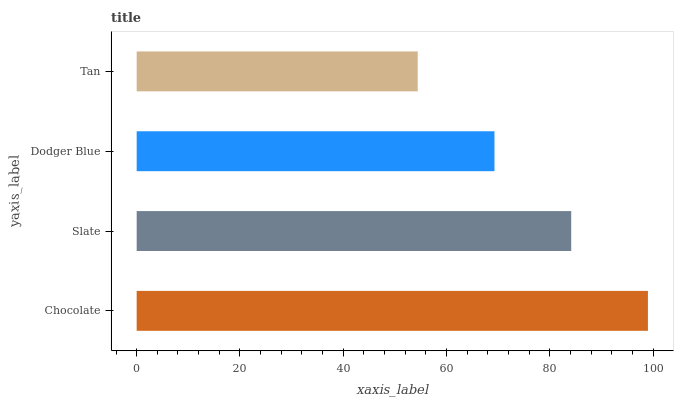Is Tan the minimum?
Answer yes or no. Yes. Is Chocolate the maximum?
Answer yes or no. Yes. Is Slate the minimum?
Answer yes or no. No. Is Slate the maximum?
Answer yes or no. No. Is Chocolate greater than Slate?
Answer yes or no. Yes. Is Slate less than Chocolate?
Answer yes or no. Yes. Is Slate greater than Chocolate?
Answer yes or no. No. Is Chocolate less than Slate?
Answer yes or no. No. Is Slate the high median?
Answer yes or no. Yes. Is Dodger Blue the low median?
Answer yes or no. Yes. Is Chocolate the high median?
Answer yes or no. No. Is Tan the low median?
Answer yes or no. No. 